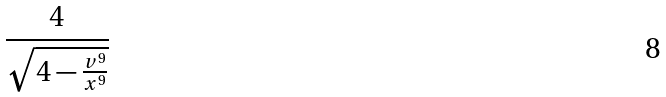Convert formula to latex. <formula><loc_0><loc_0><loc_500><loc_500>\frac { 4 } { \sqrt { 4 - \frac { v ^ { 9 } } { x ^ { 9 } } } }</formula> 